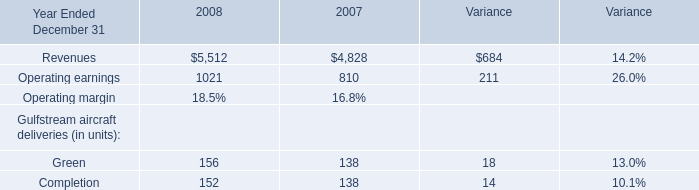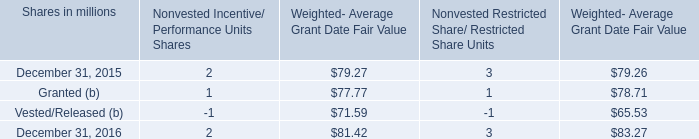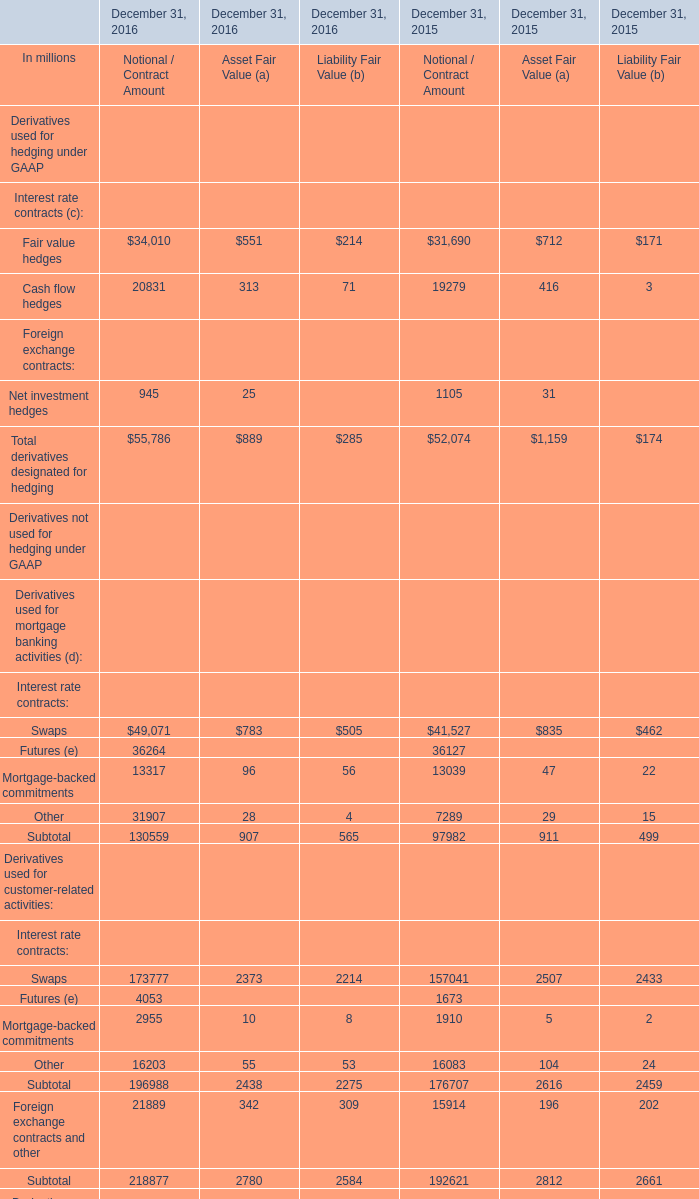In which year is Fair value hedges forNotional / Contract Amount greater than 1? 
Answer: December 31, 2016 December 31, 2015. 